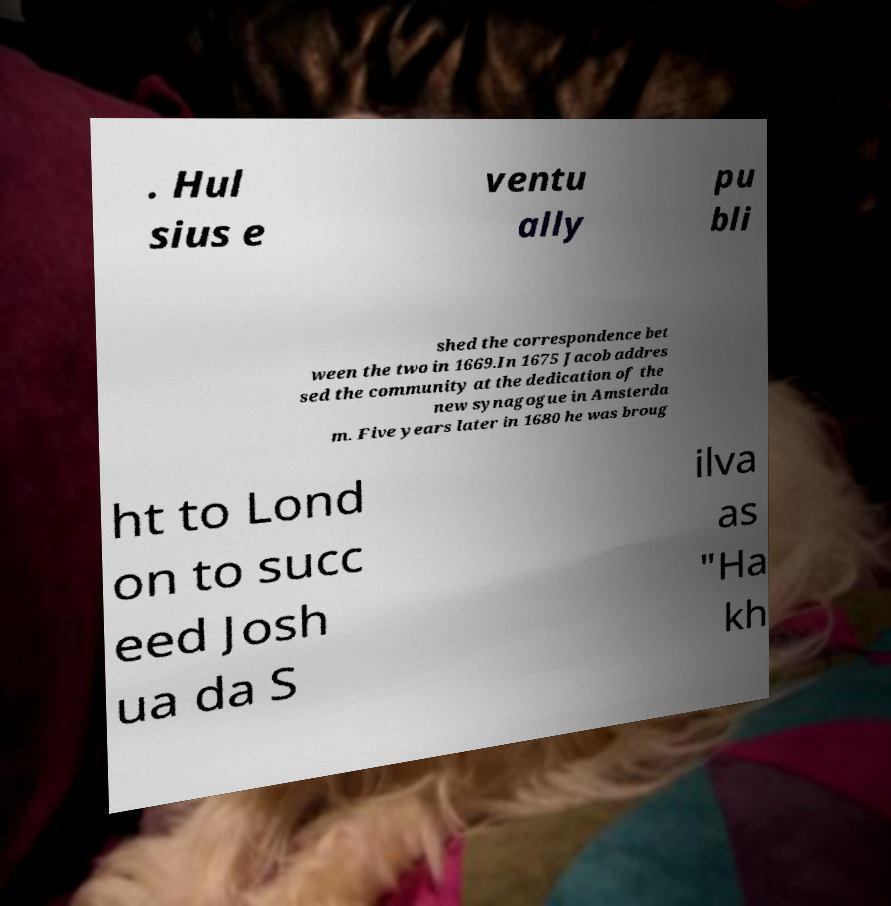There's text embedded in this image that I need extracted. Can you transcribe it verbatim? . Hul sius e ventu ally pu bli shed the correspondence bet ween the two in 1669.In 1675 Jacob addres sed the community at the dedication of the new synagogue in Amsterda m. Five years later in 1680 he was broug ht to Lond on to succ eed Josh ua da S ilva as "Ha kh 